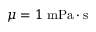Convert formula to latex. <formula><loc_0><loc_0><loc_500><loc_500>\mu = 1 \, { m P a } \cdot { s }</formula> 